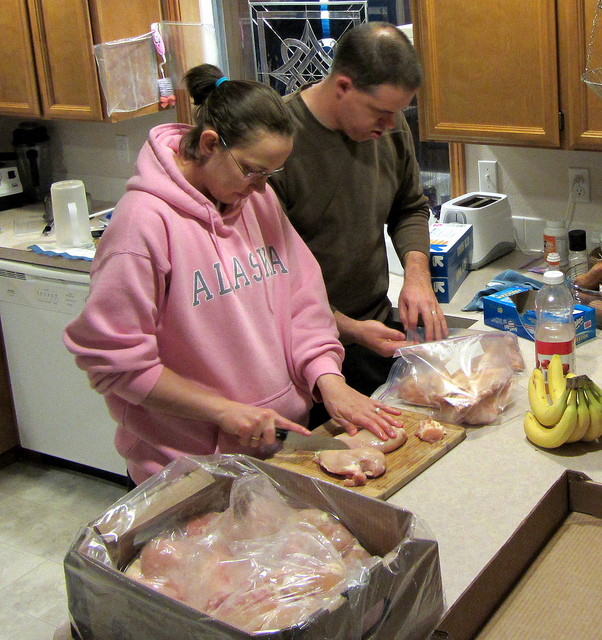Extract all visible text content from this image. ALASKA 